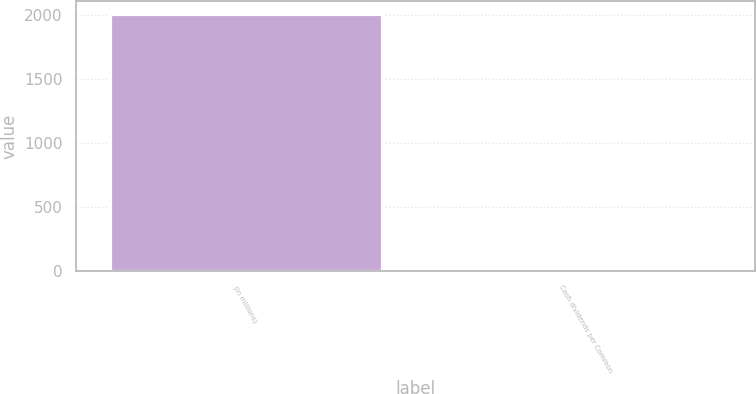<chart> <loc_0><loc_0><loc_500><loc_500><bar_chart><fcel>(in millions)<fcel>Cash dividends per Common<nl><fcel>2009<fcel>0.56<nl></chart> 